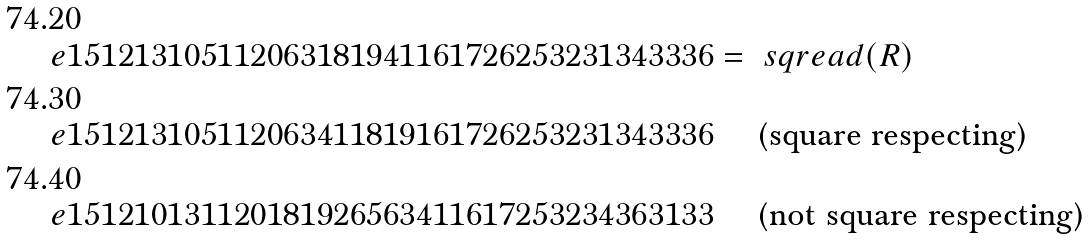<formula> <loc_0><loc_0><loc_500><loc_500>& \ e { 1 5 1 2 1 3 1 0 5 1 1 2 0 6 3 1 8 1 9 4 1 1 6 1 7 2 6 2 5 3 2 3 1 3 4 3 3 3 6 } = \ s q r e a d ( R ) \\ & \ e { 1 5 1 2 1 3 1 0 5 1 1 2 0 6 3 4 1 1 8 1 9 1 6 1 7 2 6 2 5 3 2 3 1 3 4 3 3 3 6 } \quad \text { (square respecting)} \\ & \ e { 1 5 1 2 1 0 1 3 1 1 2 0 1 8 1 9 2 6 5 6 3 4 1 1 6 1 7 2 5 3 2 3 4 3 6 3 1 3 3 } \quad \text { (not square respecting)}</formula> 